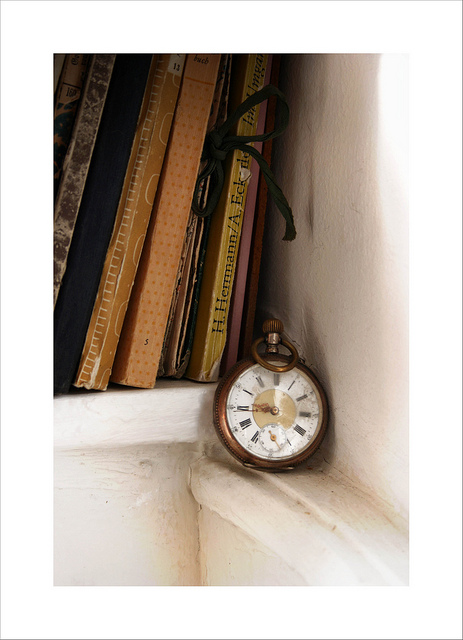Please transcribe the text in this image. H HERMANN A ECK 